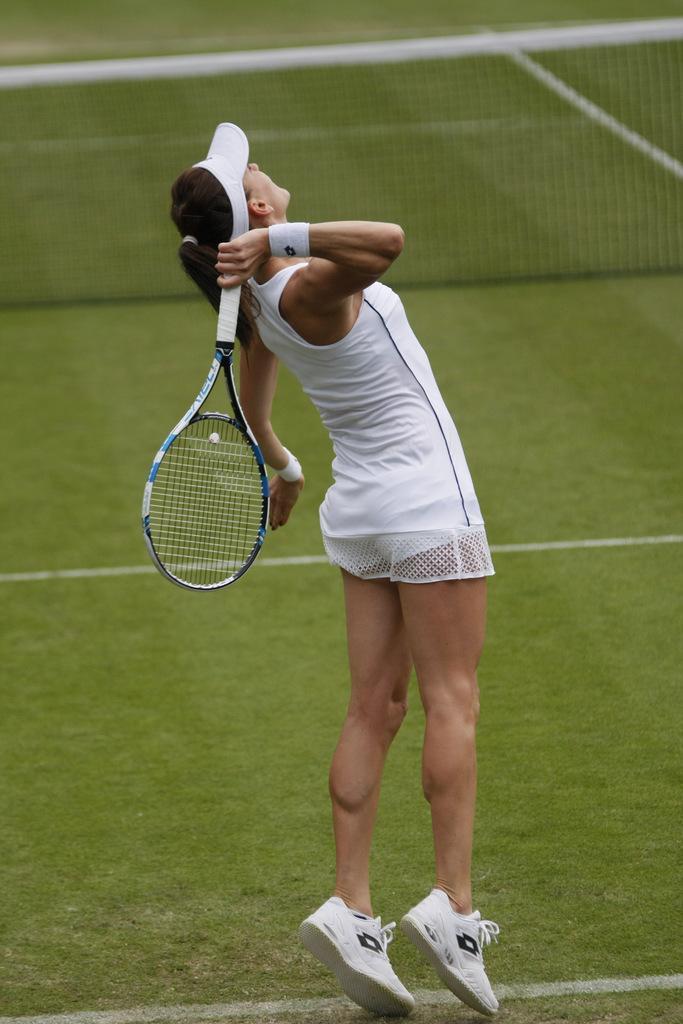Could you give a brief overview of what you see in this image? In this image we can see a lady with a badminton racket. In the background of the image there is the gross, net and an object. 